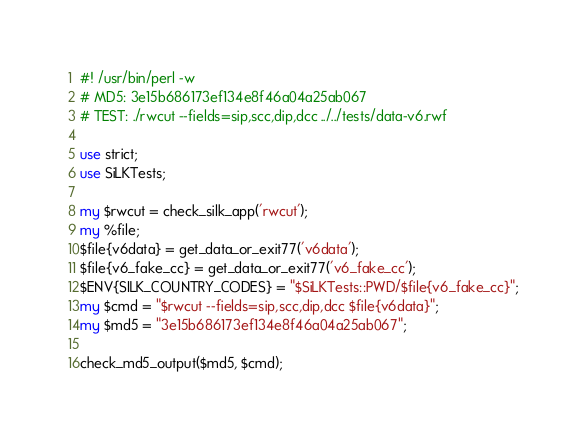<code> <loc_0><loc_0><loc_500><loc_500><_Perl_>#! /usr/bin/perl -w
# MD5: 3e15b686173ef134e8f46a04a25ab067
# TEST: ./rwcut --fields=sip,scc,dip,dcc ../../tests/data-v6.rwf

use strict;
use SiLKTests;

my $rwcut = check_silk_app('rwcut');
my %file;
$file{v6data} = get_data_or_exit77('v6data');
$file{v6_fake_cc} = get_data_or_exit77('v6_fake_cc');
$ENV{SILK_COUNTRY_CODES} = "$SiLKTests::PWD/$file{v6_fake_cc}";
my $cmd = "$rwcut --fields=sip,scc,dip,dcc $file{v6data}";
my $md5 = "3e15b686173ef134e8f46a04a25ab067";

check_md5_output($md5, $cmd);
</code> 